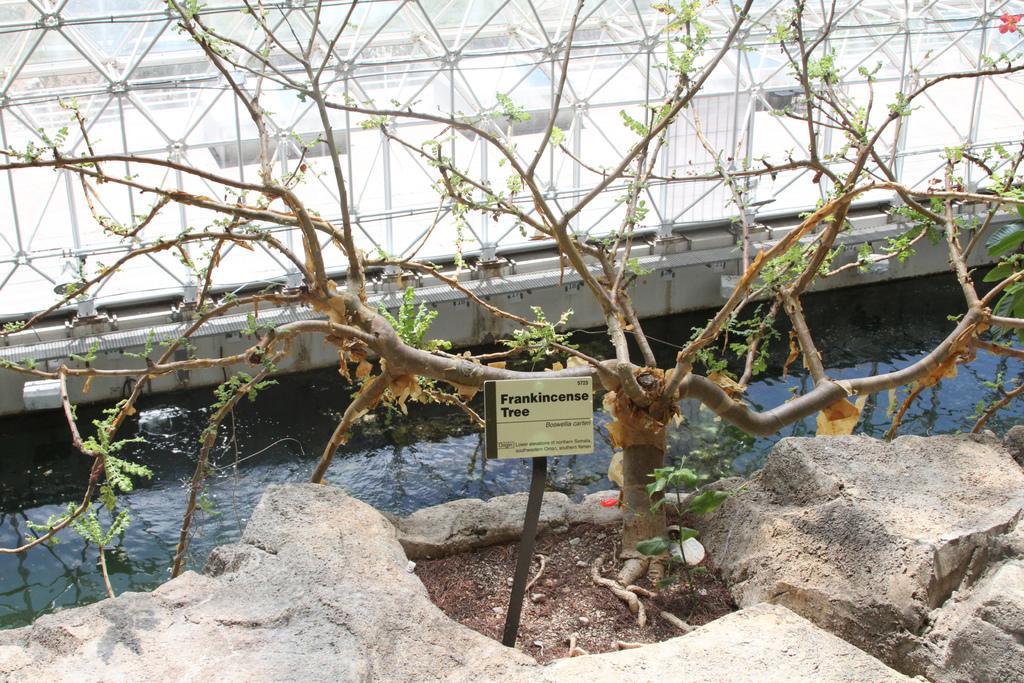Please provide a concise description of this image. This picture shows a tree and we see a rock and water and we see a nameplate to the stand. 